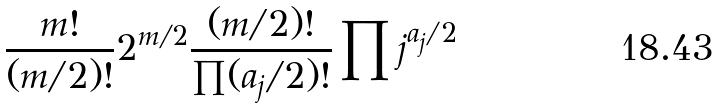<formula> <loc_0><loc_0><loc_500><loc_500>\frac { m ! } { ( m / 2 ) ! } 2 ^ { m / 2 } \frac { ( m / 2 ) ! } { \prod ( a _ { j } / 2 ) ! } \prod j ^ { a _ { j } / 2 }</formula> 